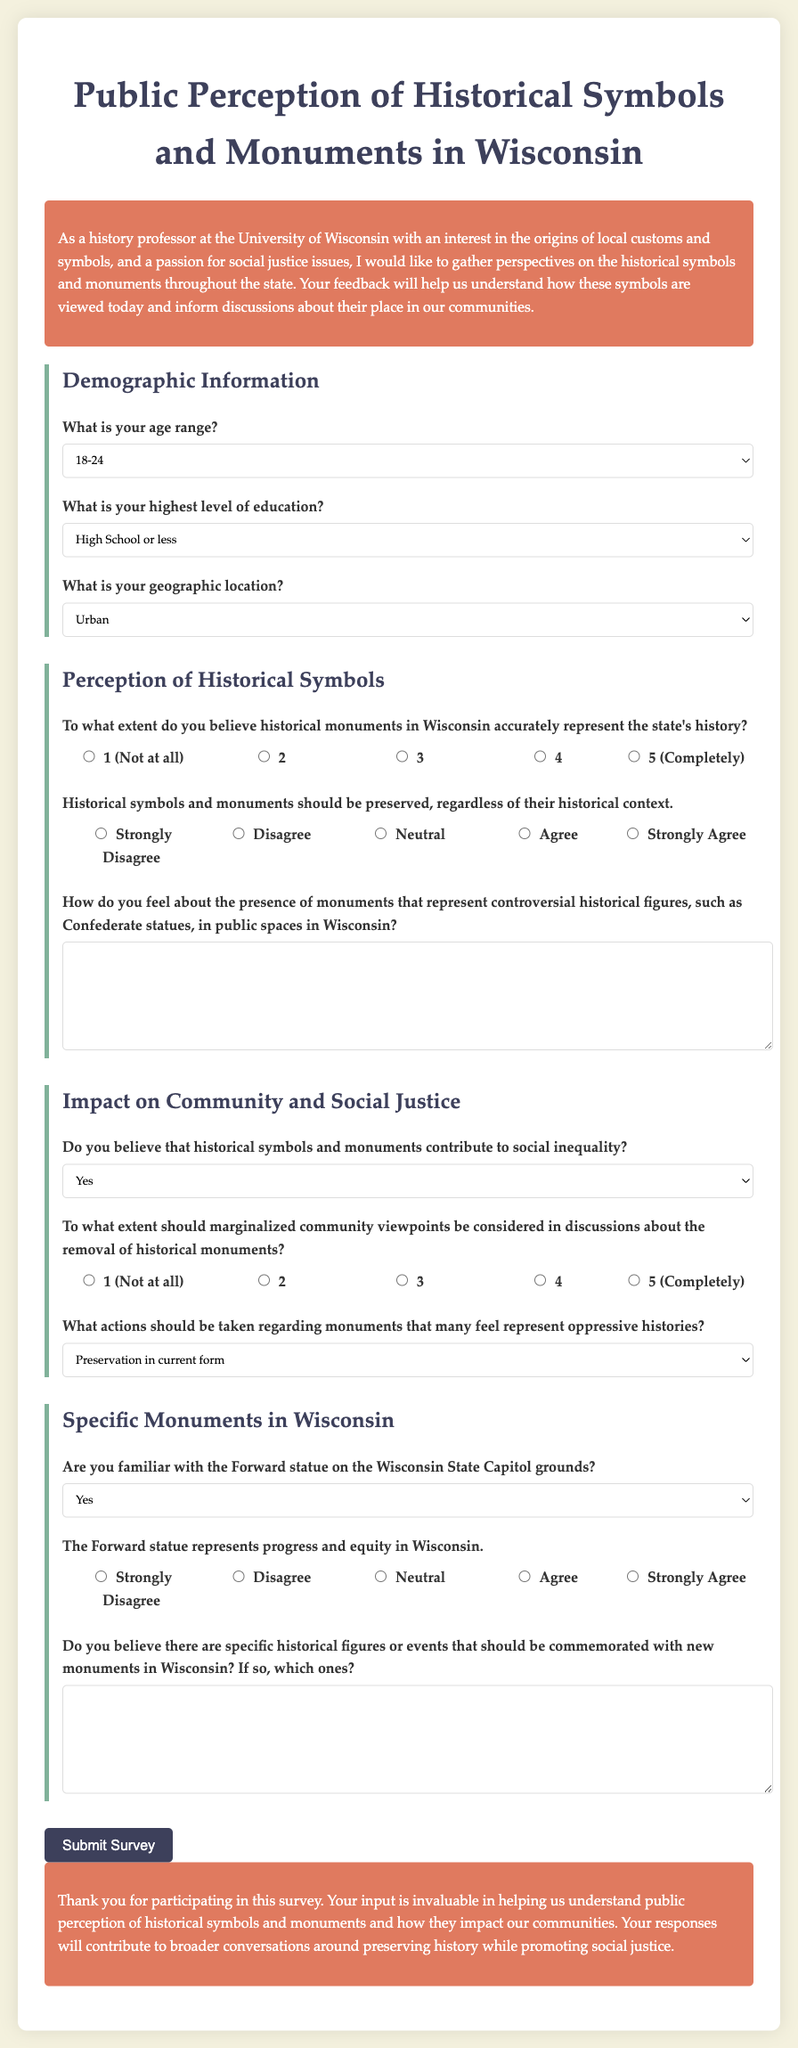What is the title of the survey? The title of the survey is stated in the document as "Public Perception of Historical Symbols and Monuments in Wisconsin."
Answer: Public Perception of Historical Symbols and Monuments in Wisconsin What is the age range option that comes before 25-34? The age range options are listed in a dropdown in the document, and 18-24 is the option that comes before 25-34.
Answer: 18-24 What is the highest level of education option listed after Bachelor's Degree? The options for education levels are in a dropdown, and Graduate or Professional Degree is listed after Bachelor's Degree.
Answer: Graduate or Professional Degree What question asks about the representation of historical monuments? The question about historical monuments is "To what extent do you believe historical monuments in Wisconsin accurately represent the state's history?"
Answer: To what extent do you believe historical monuments in Wisconsin accurately represent the state's history? Which action is suggested for monuments that represent oppressive histories? The document lists several actions regarding oppressive histories, including "Removal from public spaces" as one of the options.
Answer: Removal from public spaces To what extent should marginalized community viewpoints be considered in discussions about the removal of historical monuments? This question helps gauge the importance of marginalized views concerning historical symbols and is phrased as "To what extent should marginalized community viewpoints be considered in discussions about the removal of historical monuments?"
Answer: To what extent should marginalized community viewpoints be considered in discussions about the removal of historical monuments? What is the Likert scale range for the question about preserving historical symbols and monuments? The Likert scale for this question ranges from "Strongly Disagree" to "Strongly Agree," indicating levels of agreement.
Answer: Strongly Disagree to Strongly Agree What symbol represents progress and equity in Wisconsin? The document mentions the Forward statue on the Wisconsin State Capitol grounds as a symbol representing progress and equity.
Answer: Forward statue 